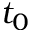Convert formula to latex. <formula><loc_0><loc_0><loc_500><loc_500>t _ { 0 }</formula> 